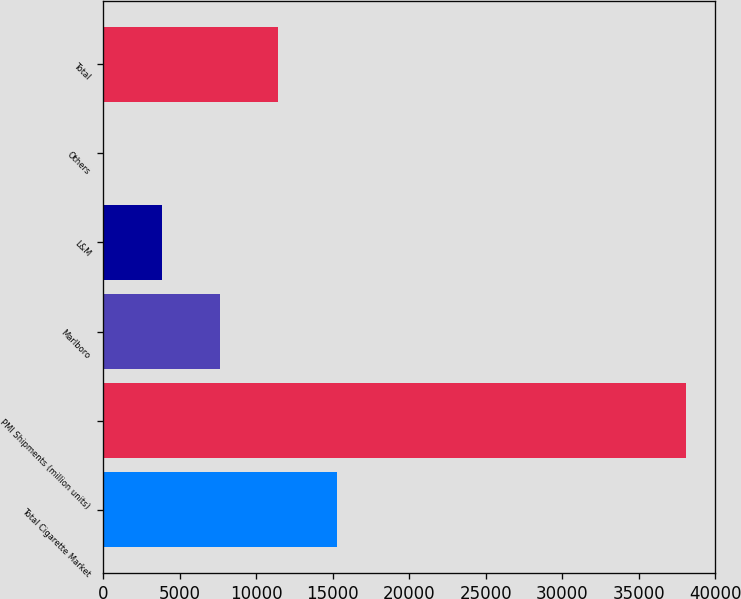<chart> <loc_0><loc_0><loc_500><loc_500><bar_chart><fcel>Total Cigarette Market<fcel>PMI Shipments (million units)<fcel>Marlboro<fcel>L&M<fcel>Others<fcel>Total<nl><fcel>15245.8<fcel>38111<fcel>7624.04<fcel>3813.17<fcel>2.3<fcel>11434.9<nl></chart> 